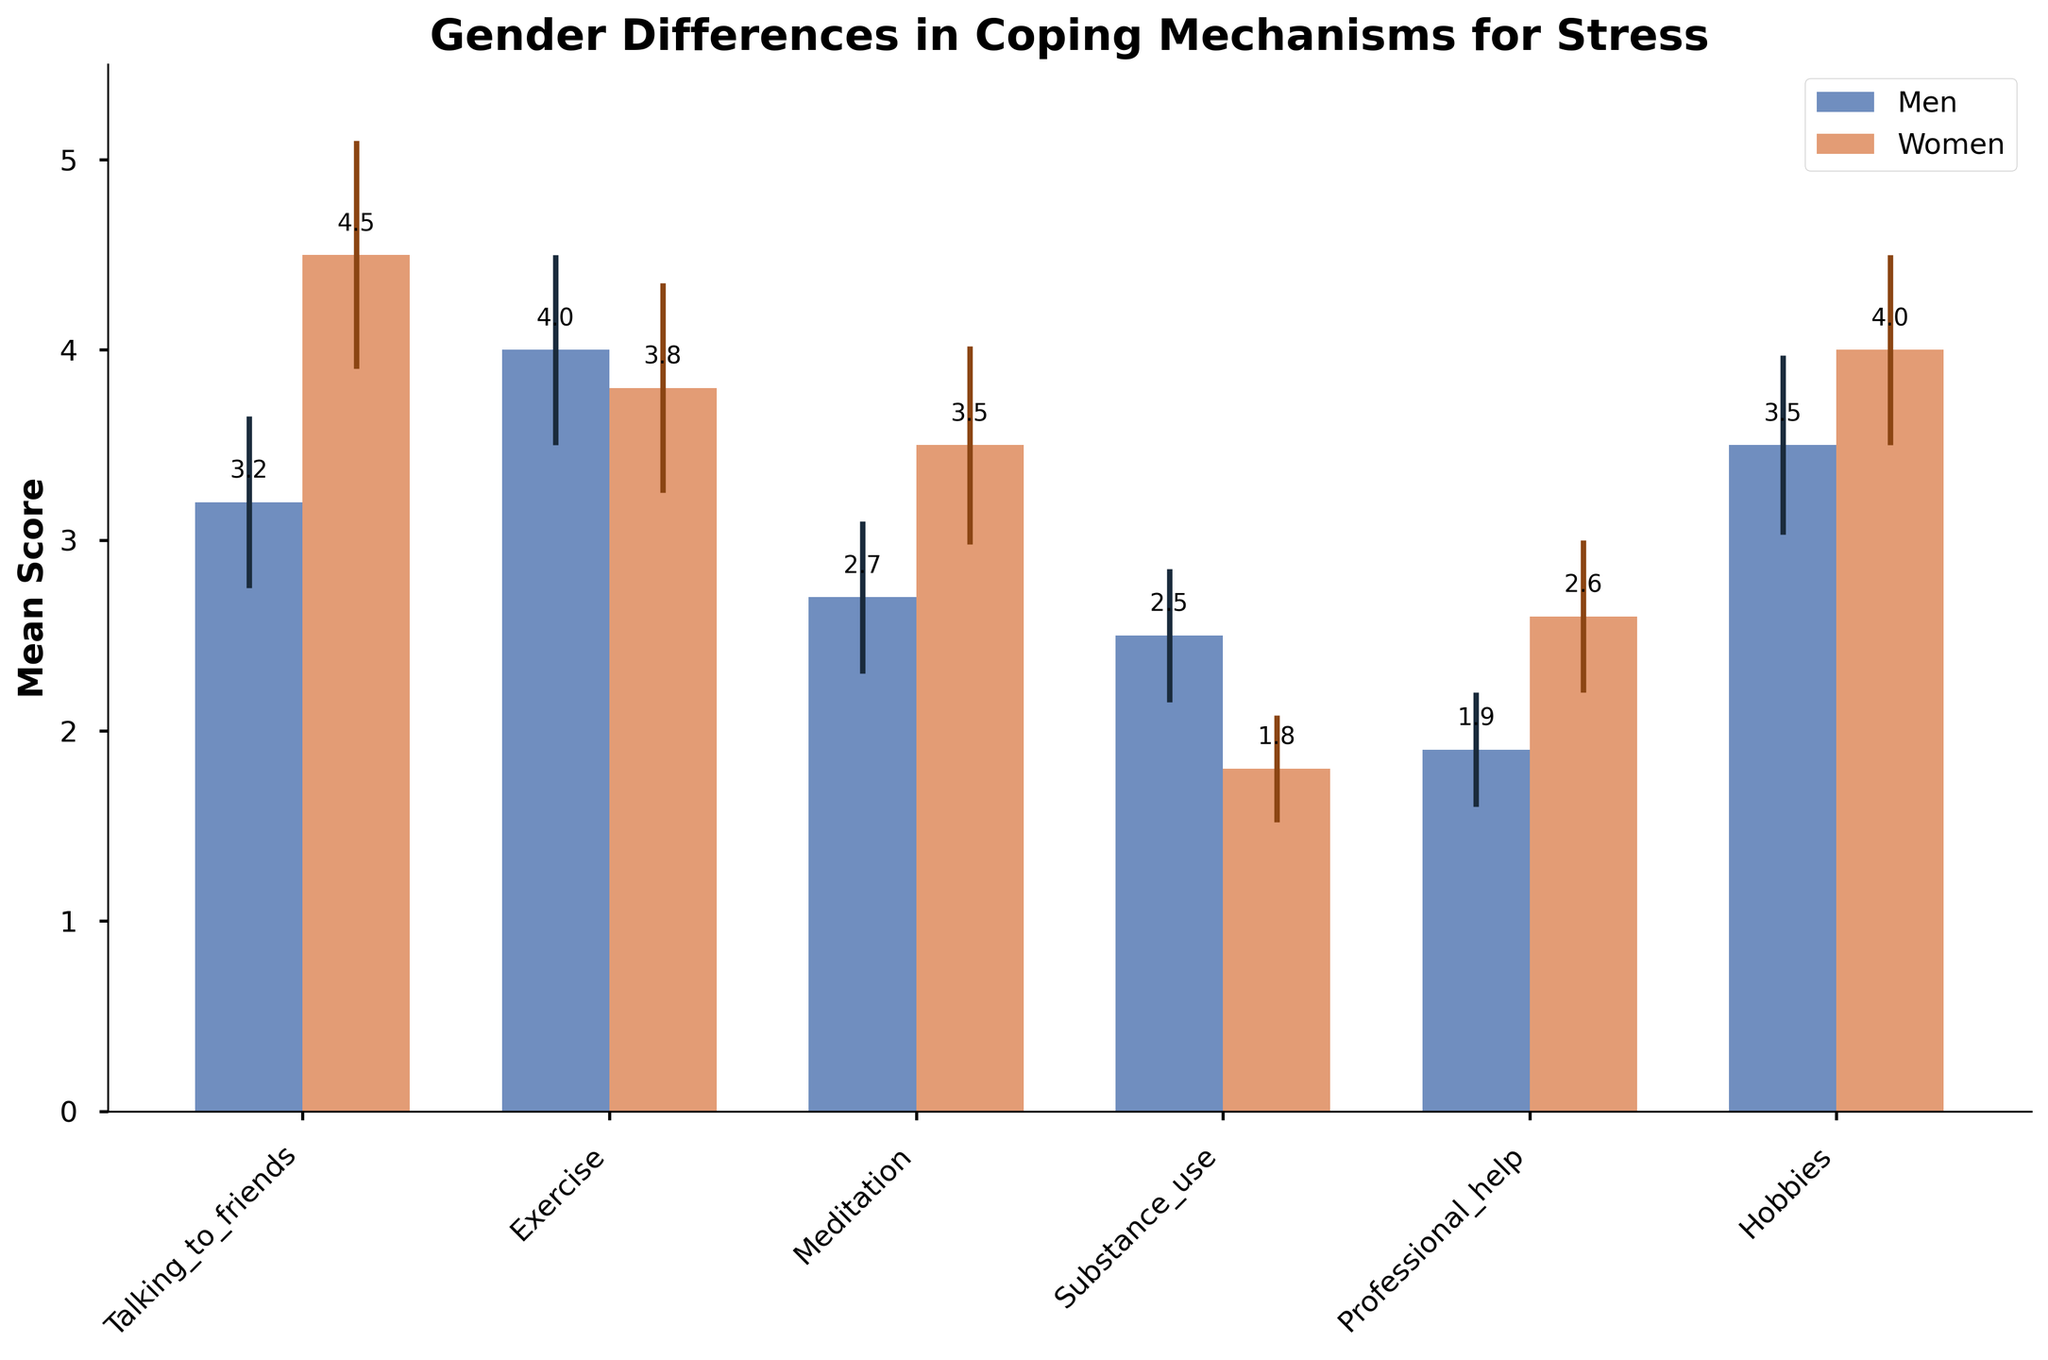What's the title of the chart? The chart title provides a summary of what the entire figure is about. It is usually positioned at the top of the figure for easy visibility.
Answer: Gender Differences in Coping Mechanisms for Stress Which coping mechanism has the highest mean score for women? By comparing the height of the bars labeled "Women," we can identify which one is the tallest, thus indicating the highest mean score.
Answer: Talking to friends What is the mean score of substance use as a coping mechanism for men? Locate the bar that represents men for the coping mechanism 'Substance_use.' The mean score is marked at the top of this bar.
Answer: 2.5 How much higher is the women's mean score for talking to friends compared to men? Calculate the difference between the mean scores of women and men for the coping mechanism 'Talking to friends' using the values provided at the top of the bars.
Answer: 1.3 Which gender has a lower mean score for professional help, and what is that score? Compare the heights of the professional help bars between men and women and select the lower one, noting the mean score displayed at the top.
Answer: Men, 1.9 What is the confidence interval for exercise in women? Confidence intervals are indicated with error bars. Look at the error bars atop the 'Exercise' bar for women. The length represents the confidence interval.
Answer: 0.55 What is the mean score and confidence interval for hobbies for men? Look at the bar labeled 'Hobbies' for men on the x-axis. The mean score is at the top of the bar and the confidence interval is represented by the length of the error bar.
Answer: Mean: 3.5, Confidence Interval: 0.47 Which coping mechanism shows the greatest mean difference between men and women? Calculate the absolute differences between the mean scores of men and women for each coping mechanism. Identify the pair with the largest difference.
Answer: Talking to friends, with a difference of 1.3 points Is there any coping mechanism where men's mean score is higher than women's? Compare the heights of the bars for each coping mechanism between men and women. Identify any where the men's bar is taller.
Answer: Exercise Comparing meditation and substance use, which coping mechanism do women use more frequently? Look at the heights of the bars representing 'Meditation' and 'Substance use' for women. The taller bar indicates the more frequently used coping mechanism.
Answer: Meditation What can you infer about the confidence intervals in the data? Examine the consistency of the error bars across all coping mechanisms. The length indicates the variation or uncertainty in the mean scores' estimates. Generally, wider intervals suggest greater variability in the data.
Answer: The confidence intervals show variability, with women having wider intervals in some coping mechanisms like 'Talking to friends.' 